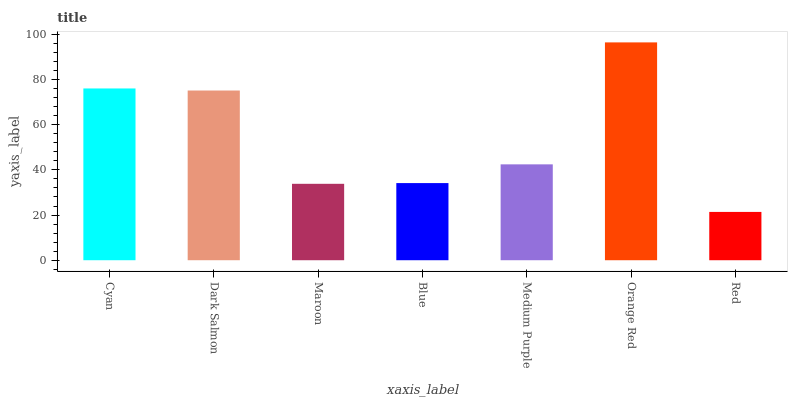Is Dark Salmon the minimum?
Answer yes or no. No. Is Dark Salmon the maximum?
Answer yes or no. No. Is Cyan greater than Dark Salmon?
Answer yes or no. Yes. Is Dark Salmon less than Cyan?
Answer yes or no. Yes. Is Dark Salmon greater than Cyan?
Answer yes or no. No. Is Cyan less than Dark Salmon?
Answer yes or no. No. Is Medium Purple the high median?
Answer yes or no. Yes. Is Medium Purple the low median?
Answer yes or no. Yes. Is Orange Red the high median?
Answer yes or no. No. Is Blue the low median?
Answer yes or no. No. 